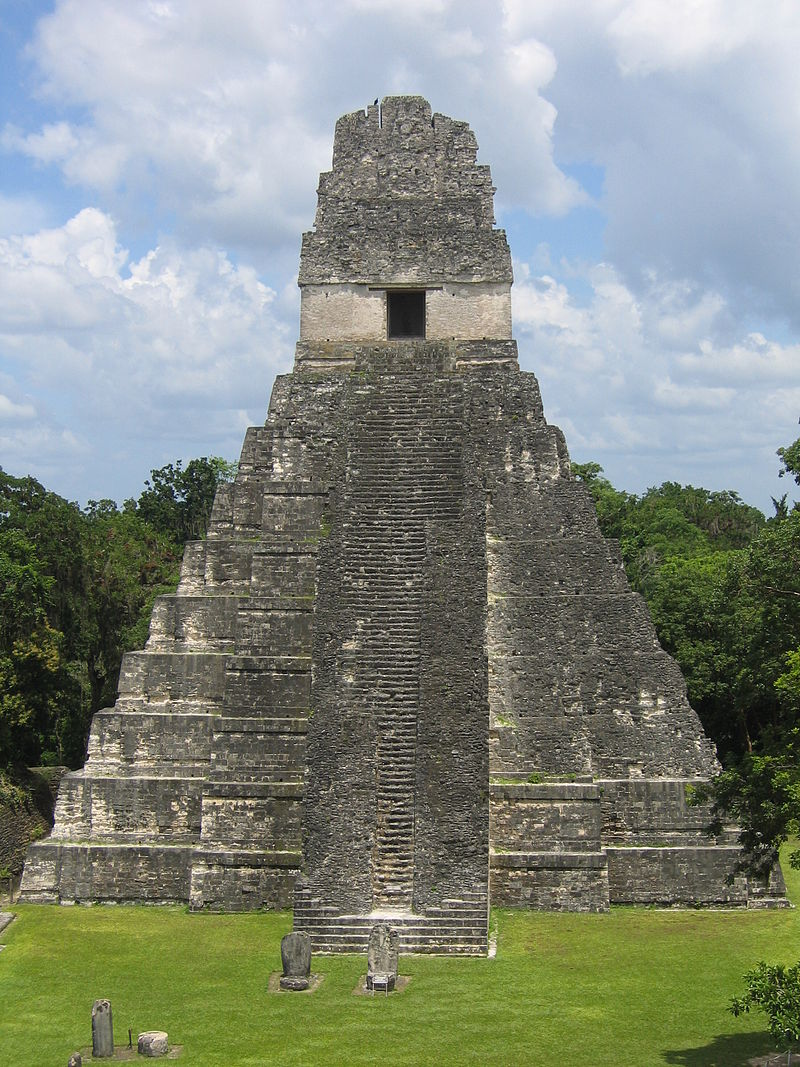What other notable features does Tikal Temple I have? Apart from its towering height and nine distinct levels, Tikal Temple I features a steep staircase leading to the top temple structure. The stonework is intricately designed with a minimalist yet powerful aesthetic. At the base, there are several stelae and altars, demonstrating the temple's role in ancient Mayan ceremonies. The top structure served both as a temple and a burial site, likely for one of Tikal's great rulers, believed to be Jasaw Chan K'awiil I. 